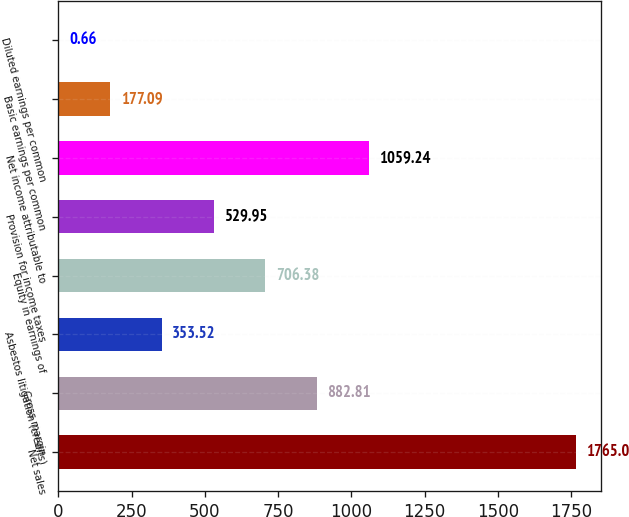Convert chart to OTSL. <chart><loc_0><loc_0><loc_500><loc_500><bar_chart><fcel>Net sales<fcel>Gross margin<fcel>Asbestos litigation (credits)<fcel>Equity in earnings of<fcel>Provision for income taxes<fcel>Net income attributable to<fcel>Basic earnings per common<fcel>Diluted earnings per common<nl><fcel>1765<fcel>882.81<fcel>353.52<fcel>706.38<fcel>529.95<fcel>1059.24<fcel>177.09<fcel>0.66<nl></chart> 